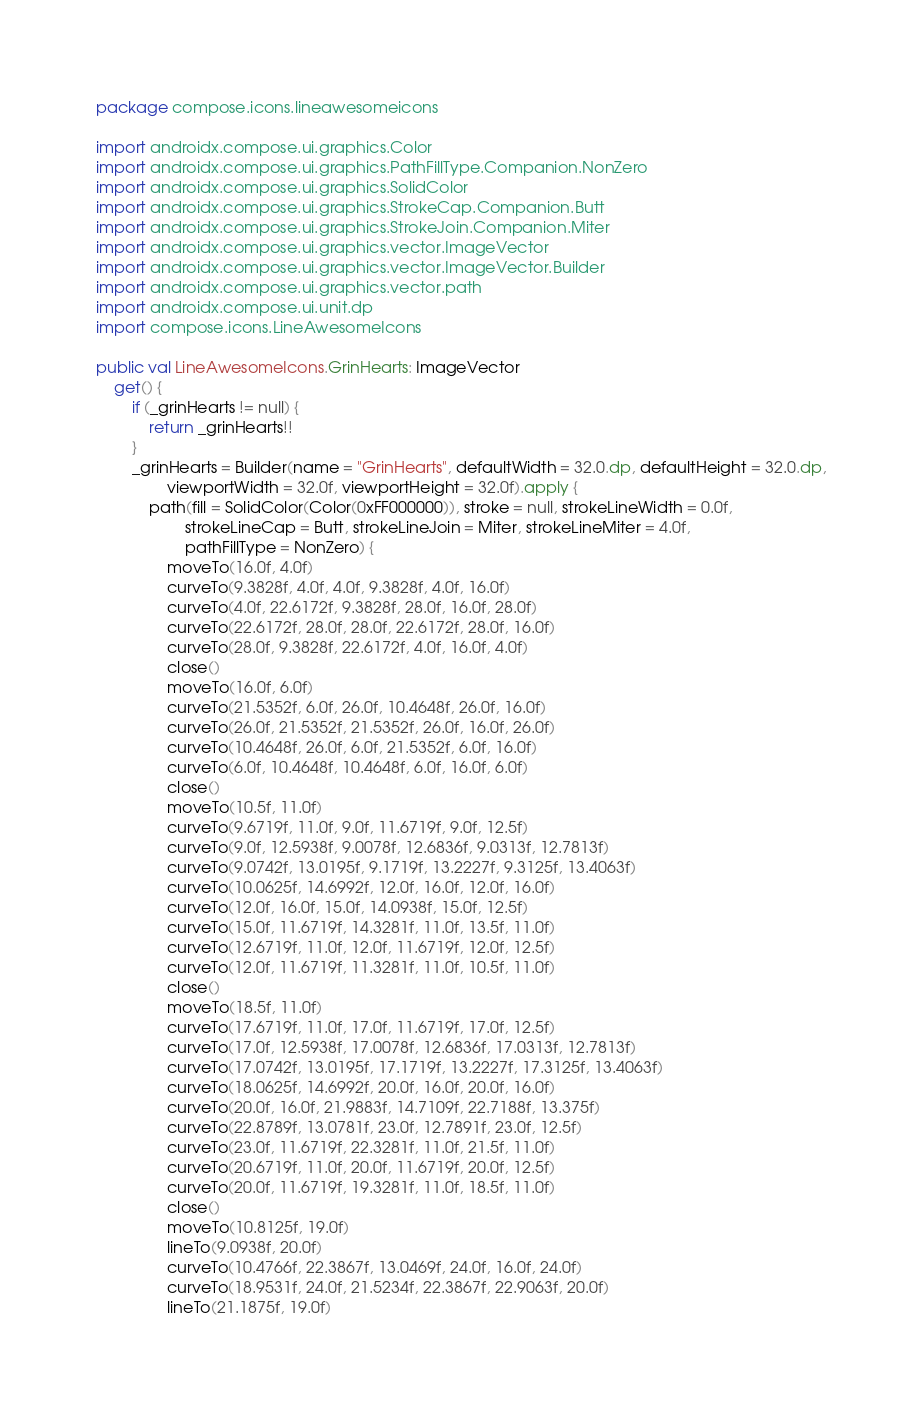<code> <loc_0><loc_0><loc_500><loc_500><_Kotlin_>package compose.icons.lineawesomeicons

import androidx.compose.ui.graphics.Color
import androidx.compose.ui.graphics.PathFillType.Companion.NonZero
import androidx.compose.ui.graphics.SolidColor
import androidx.compose.ui.graphics.StrokeCap.Companion.Butt
import androidx.compose.ui.graphics.StrokeJoin.Companion.Miter
import androidx.compose.ui.graphics.vector.ImageVector
import androidx.compose.ui.graphics.vector.ImageVector.Builder
import androidx.compose.ui.graphics.vector.path
import androidx.compose.ui.unit.dp
import compose.icons.LineAwesomeIcons

public val LineAwesomeIcons.GrinHearts: ImageVector
    get() {
        if (_grinHearts != null) {
            return _grinHearts!!
        }
        _grinHearts = Builder(name = "GrinHearts", defaultWidth = 32.0.dp, defaultHeight = 32.0.dp,
                viewportWidth = 32.0f, viewportHeight = 32.0f).apply {
            path(fill = SolidColor(Color(0xFF000000)), stroke = null, strokeLineWidth = 0.0f,
                    strokeLineCap = Butt, strokeLineJoin = Miter, strokeLineMiter = 4.0f,
                    pathFillType = NonZero) {
                moveTo(16.0f, 4.0f)
                curveTo(9.3828f, 4.0f, 4.0f, 9.3828f, 4.0f, 16.0f)
                curveTo(4.0f, 22.6172f, 9.3828f, 28.0f, 16.0f, 28.0f)
                curveTo(22.6172f, 28.0f, 28.0f, 22.6172f, 28.0f, 16.0f)
                curveTo(28.0f, 9.3828f, 22.6172f, 4.0f, 16.0f, 4.0f)
                close()
                moveTo(16.0f, 6.0f)
                curveTo(21.5352f, 6.0f, 26.0f, 10.4648f, 26.0f, 16.0f)
                curveTo(26.0f, 21.5352f, 21.5352f, 26.0f, 16.0f, 26.0f)
                curveTo(10.4648f, 26.0f, 6.0f, 21.5352f, 6.0f, 16.0f)
                curveTo(6.0f, 10.4648f, 10.4648f, 6.0f, 16.0f, 6.0f)
                close()
                moveTo(10.5f, 11.0f)
                curveTo(9.6719f, 11.0f, 9.0f, 11.6719f, 9.0f, 12.5f)
                curveTo(9.0f, 12.5938f, 9.0078f, 12.6836f, 9.0313f, 12.7813f)
                curveTo(9.0742f, 13.0195f, 9.1719f, 13.2227f, 9.3125f, 13.4063f)
                curveTo(10.0625f, 14.6992f, 12.0f, 16.0f, 12.0f, 16.0f)
                curveTo(12.0f, 16.0f, 15.0f, 14.0938f, 15.0f, 12.5f)
                curveTo(15.0f, 11.6719f, 14.3281f, 11.0f, 13.5f, 11.0f)
                curveTo(12.6719f, 11.0f, 12.0f, 11.6719f, 12.0f, 12.5f)
                curveTo(12.0f, 11.6719f, 11.3281f, 11.0f, 10.5f, 11.0f)
                close()
                moveTo(18.5f, 11.0f)
                curveTo(17.6719f, 11.0f, 17.0f, 11.6719f, 17.0f, 12.5f)
                curveTo(17.0f, 12.5938f, 17.0078f, 12.6836f, 17.0313f, 12.7813f)
                curveTo(17.0742f, 13.0195f, 17.1719f, 13.2227f, 17.3125f, 13.4063f)
                curveTo(18.0625f, 14.6992f, 20.0f, 16.0f, 20.0f, 16.0f)
                curveTo(20.0f, 16.0f, 21.9883f, 14.7109f, 22.7188f, 13.375f)
                curveTo(22.8789f, 13.0781f, 23.0f, 12.7891f, 23.0f, 12.5f)
                curveTo(23.0f, 11.6719f, 22.3281f, 11.0f, 21.5f, 11.0f)
                curveTo(20.6719f, 11.0f, 20.0f, 11.6719f, 20.0f, 12.5f)
                curveTo(20.0f, 11.6719f, 19.3281f, 11.0f, 18.5f, 11.0f)
                close()
                moveTo(10.8125f, 19.0f)
                lineTo(9.0938f, 20.0f)
                curveTo(10.4766f, 22.3867f, 13.0469f, 24.0f, 16.0f, 24.0f)
                curveTo(18.9531f, 24.0f, 21.5234f, 22.3867f, 22.9063f, 20.0f)
                lineTo(21.1875f, 19.0f)</code> 